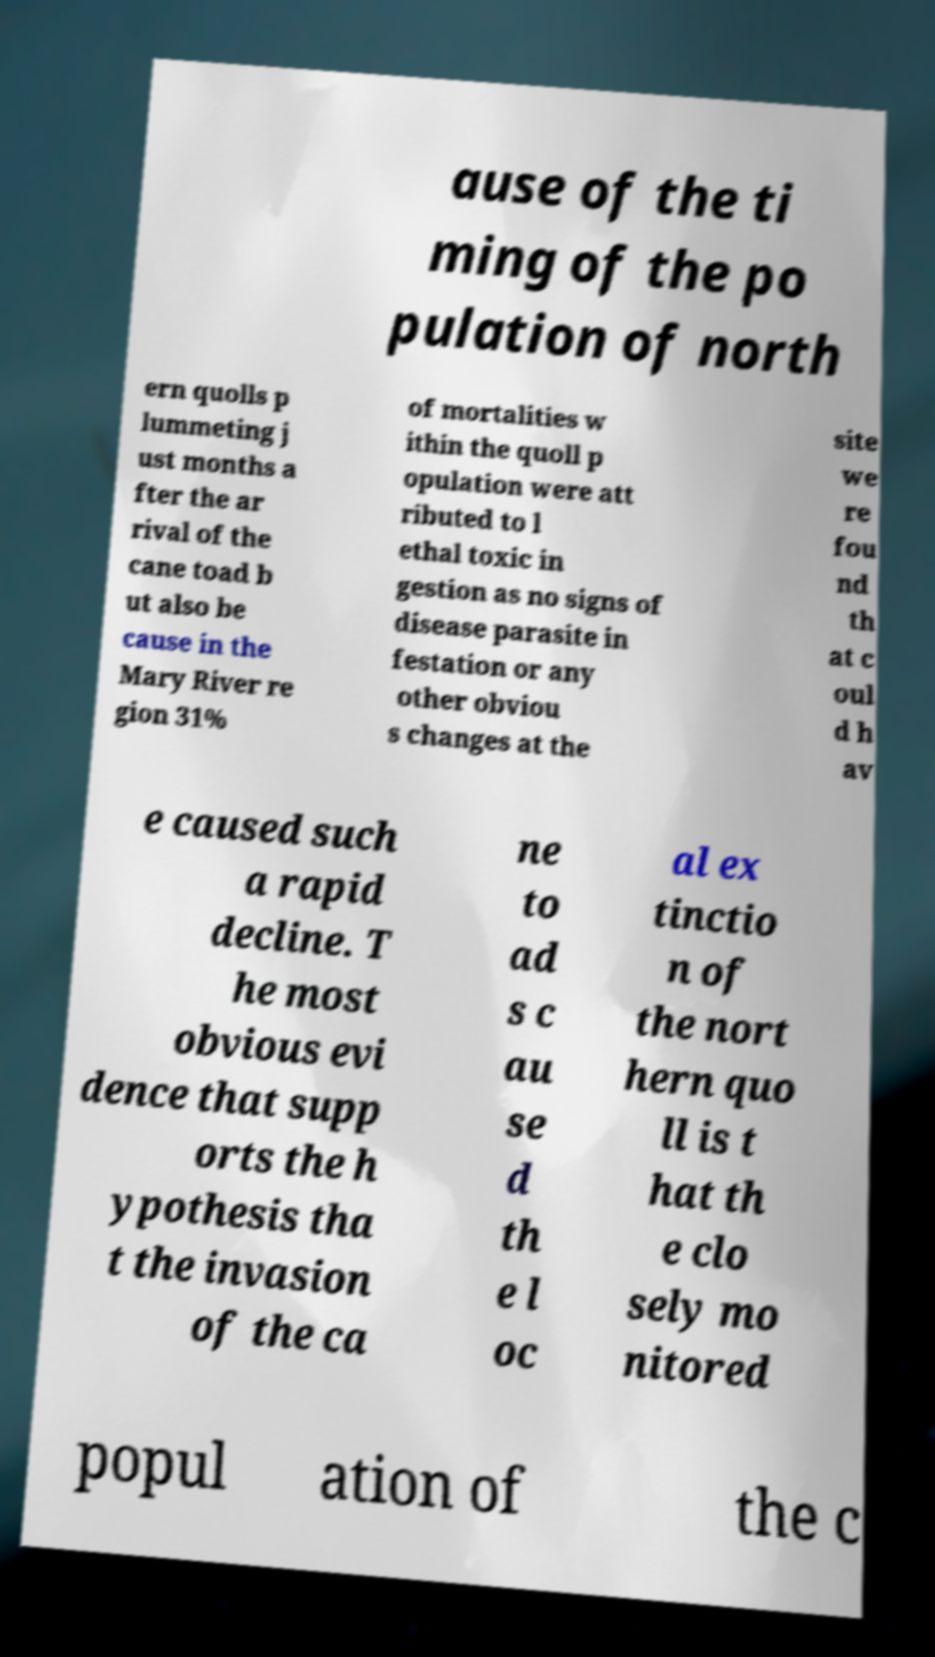For documentation purposes, I need the text within this image transcribed. Could you provide that? ause of the ti ming of the po pulation of north ern quolls p lummeting j ust months a fter the ar rival of the cane toad b ut also be cause in the Mary River re gion 31% of mortalities w ithin the quoll p opulation were att ributed to l ethal toxic in gestion as no signs of disease parasite in festation or any other obviou s changes at the site we re fou nd th at c oul d h av e caused such a rapid decline. T he most obvious evi dence that supp orts the h ypothesis tha t the invasion of the ca ne to ad s c au se d th e l oc al ex tinctio n of the nort hern quo ll is t hat th e clo sely mo nitored popul ation of the c 